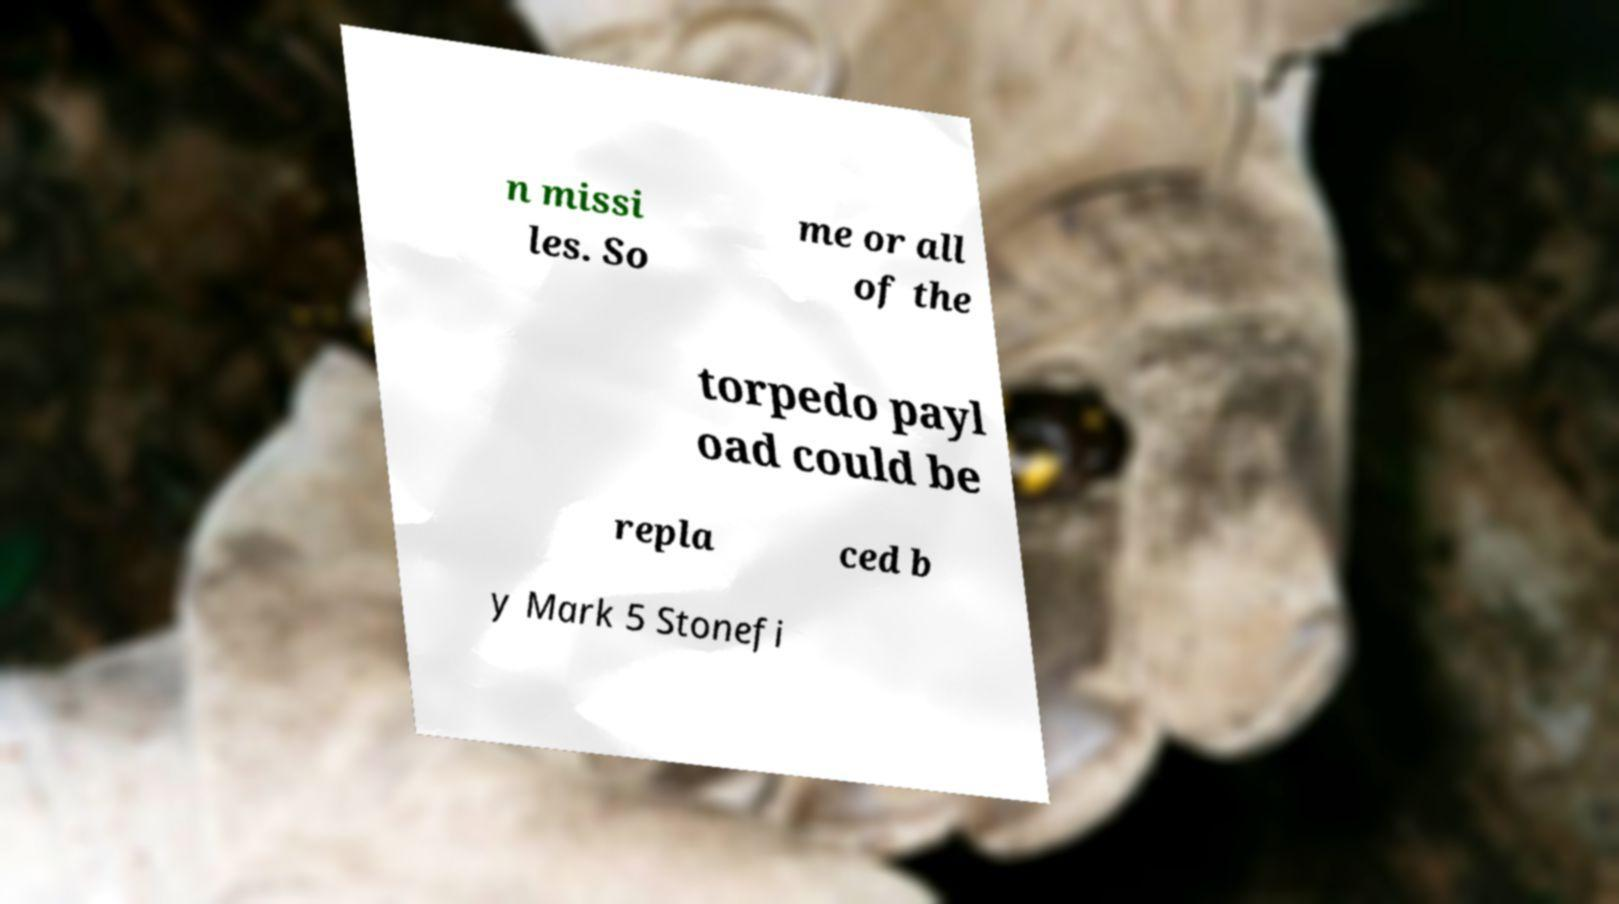I need the written content from this picture converted into text. Can you do that? n missi les. So me or all of the torpedo payl oad could be repla ced b y Mark 5 Stonefi 